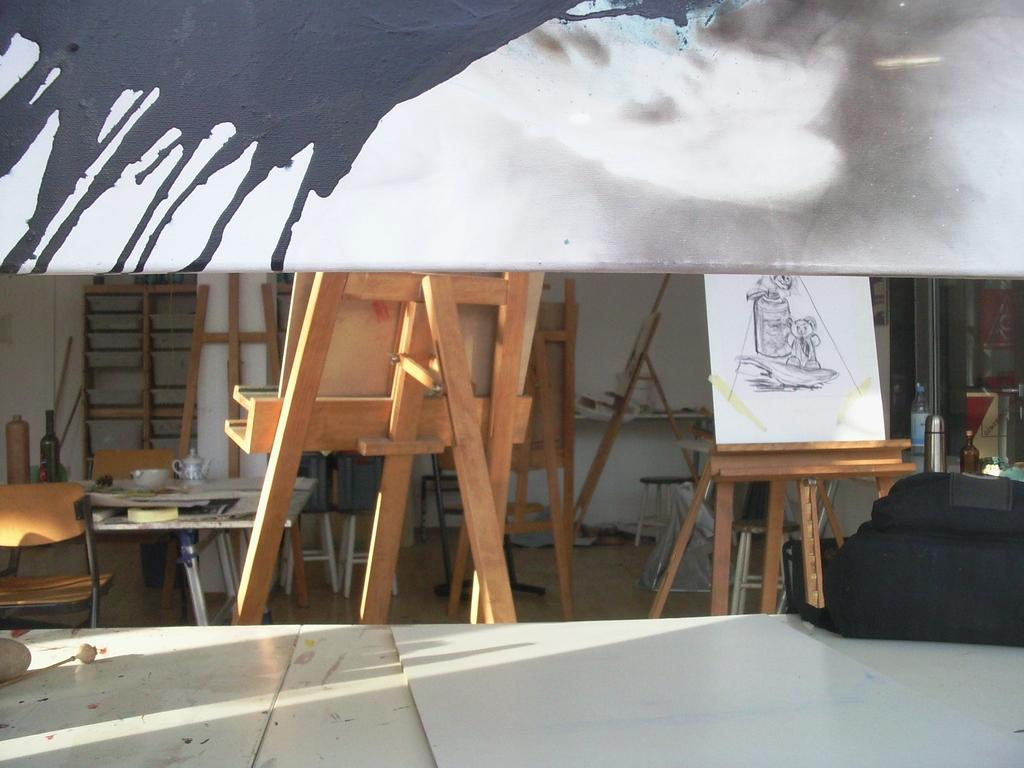What objects can be seen on the tables in the image? There are bottles, a bag, and a bowl on the tables in the image. Are there any other items on the tables? Yes, there are other things on the tables. What can be seen in the background of the image? There are painting boards and a painting on a paper in the background. What type of jeans is the person wearing in the image? There is no person wearing jeans in the image; it only shows tables, bottles, a bag, a bowl, painting boards, and a painting on a paper. 